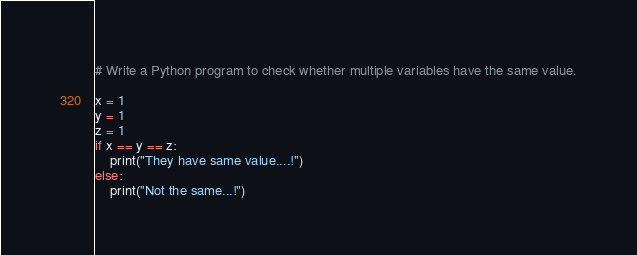Convert code to text. <code><loc_0><loc_0><loc_500><loc_500><_Python_># Write a Python program to check whether multiple variables have the same value.

x = 1
y = 1
z = 1
if x == y == z:
    print("They have same value....!")
else:
    print("Not the same...!")
</code> 